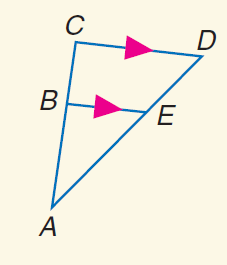Answer the mathemtical geometry problem and directly provide the correct option letter.
Question: Find E D if A B = 6, B C = 4, and A E = 9.
Choices: A: 3 B: 6 C: 9 D: 13.5 B 